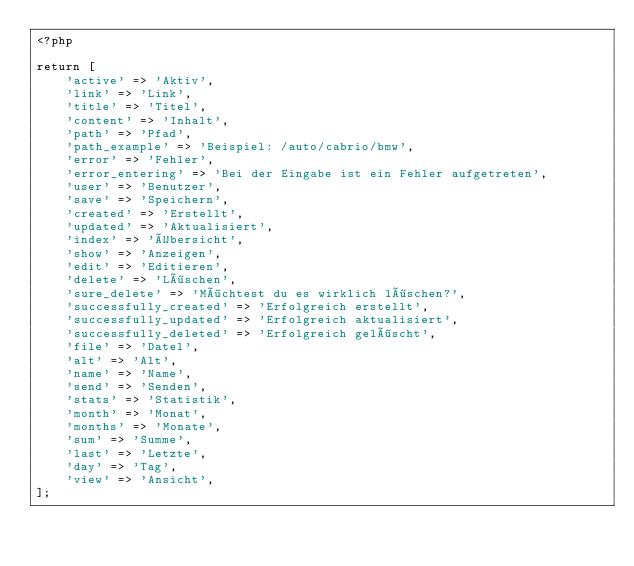<code> <loc_0><loc_0><loc_500><loc_500><_PHP_><?php

return [
    'active' => 'Aktiv',
    'link' => 'Link',
    'title' => 'Titel',
    'content' => 'Inhalt',
    'path' => 'Pfad',
    'path_example' => 'Beispiel: /auto/cabrio/bmw',
    'error' => 'Fehler',
    'error_entering' => 'Bei der Eingabe ist ein Fehler aufgetreten',
    'user' => 'Benutzer',
    'save' => 'Speichern',
    'created' => 'Erstellt',
    'updated' => 'Aktualisiert',
    'index' => 'Übersicht',
    'show' => 'Anzeigen',
    'edit' => 'Editieren',
    'delete' => 'Löschen',
    'sure_delete' => 'Möchtest du es wirklich löschen?',
    'successfully_created' => 'Erfolgreich erstellt',
    'successfully_updated' => 'Erfolgreich aktualisiert',
    'successfully_deleted' => 'Erfolgreich gelöscht',
    'file' => 'Datel',
    'alt' => 'Alt',
    'name' => 'Name',
    'send' => 'Senden',
    'stats' => 'Statistik',
    'month' => 'Monat',
    'months' => 'Monate',
    'sum' => 'Summe',
    'last' => 'Letzte',
    'day' => 'Tag',
    'view' => 'Ansicht',
];
</code> 